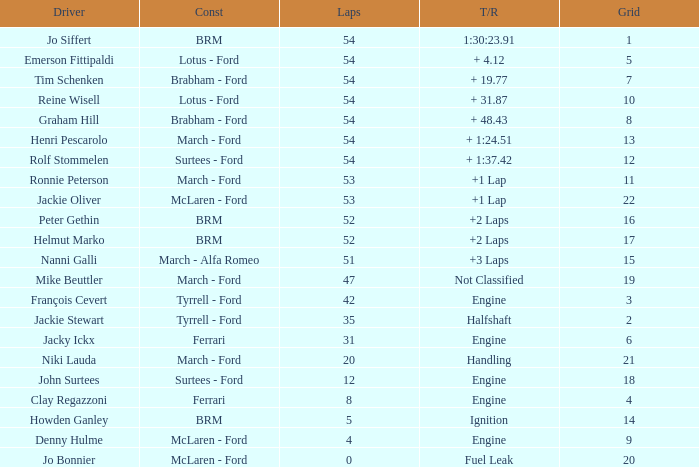What is the average grid that has over 8 laps, a Time/Retired of +2 laps, and peter gethin driving? 16.0. 